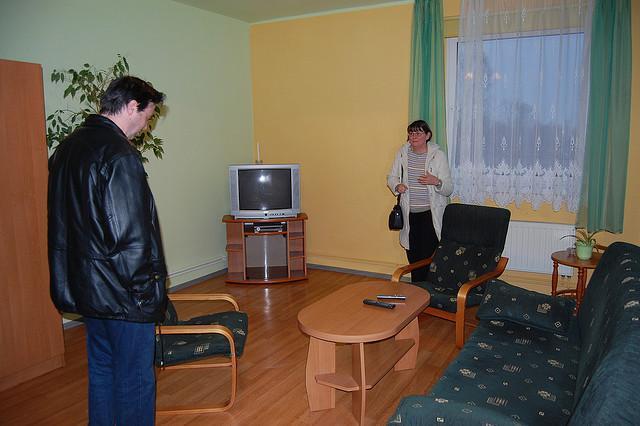How many bottled waters are there on the table?
Give a very brief answer. 0. How many people are visible?
Give a very brief answer. 2. How many chairs are there?
Give a very brief answer. 2. How many tvs are there?
Give a very brief answer. 1. 